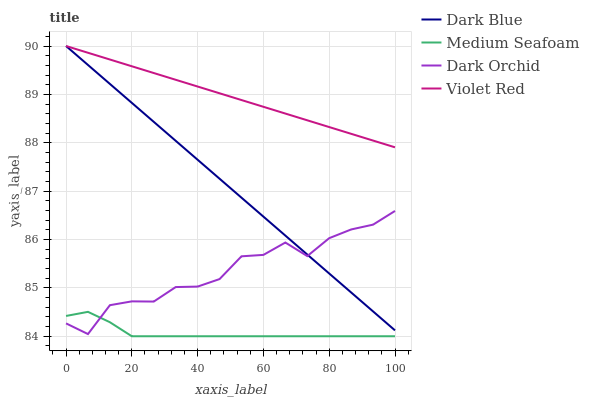Does Medium Seafoam have the minimum area under the curve?
Answer yes or no. Yes. Does Violet Red have the maximum area under the curve?
Answer yes or no. Yes. Does Violet Red have the minimum area under the curve?
Answer yes or no. No. Does Medium Seafoam have the maximum area under the curve?
Answer yes or no. No. Is Dark Blue the smoothest?
Answer yes or no. Yes. Is Dark Orchid the roughest?
Answer yes or no. Yes. Is Violet Red the smoothest?
Answer yes or no. No. Is Violet Red the roughest?
Answer yes or no. No. Does Medium Seafoam have the lowest value?
Answer yes or no. Yes. Does Violet Red have the lowest value?
Answer yes or no. No. Does Violet Red have the highest value?
Answer yes or no. Yes. Does Medium Seafoam have the highest value?
Answer yes or no. No. Is Medium Seafoam less than Violet Red?
Answer yes or no. Yes. Is Violet Red greater than Dark Orchid?
Answer yes or no. Yes. Does Violet Red intersect Dark Blue?
Answer yes or no. Yes. Is Violet Red less than Dark Blue?
Answer yes or no. No. Is Violet Red greater than Dark Blue?
Answer yes or no. No. Does Medium Seafoam intersect Violet Red?
Answer yes or no. No. 